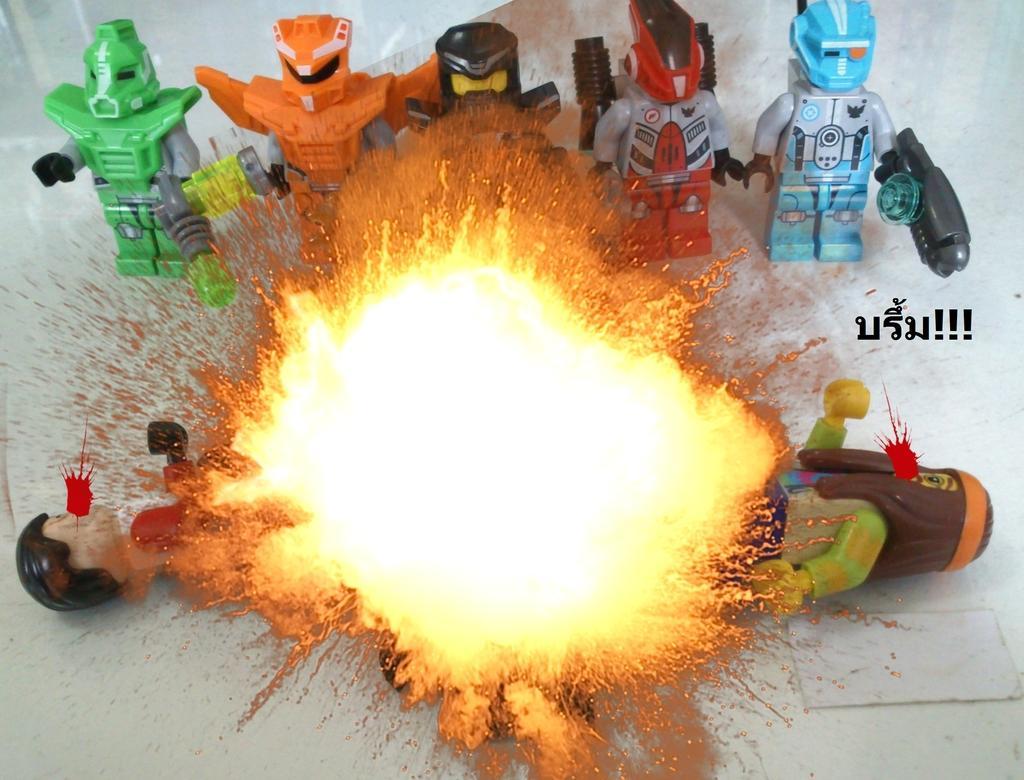Describe this image in one or two sentences. In this picture we can see toys and fire. 